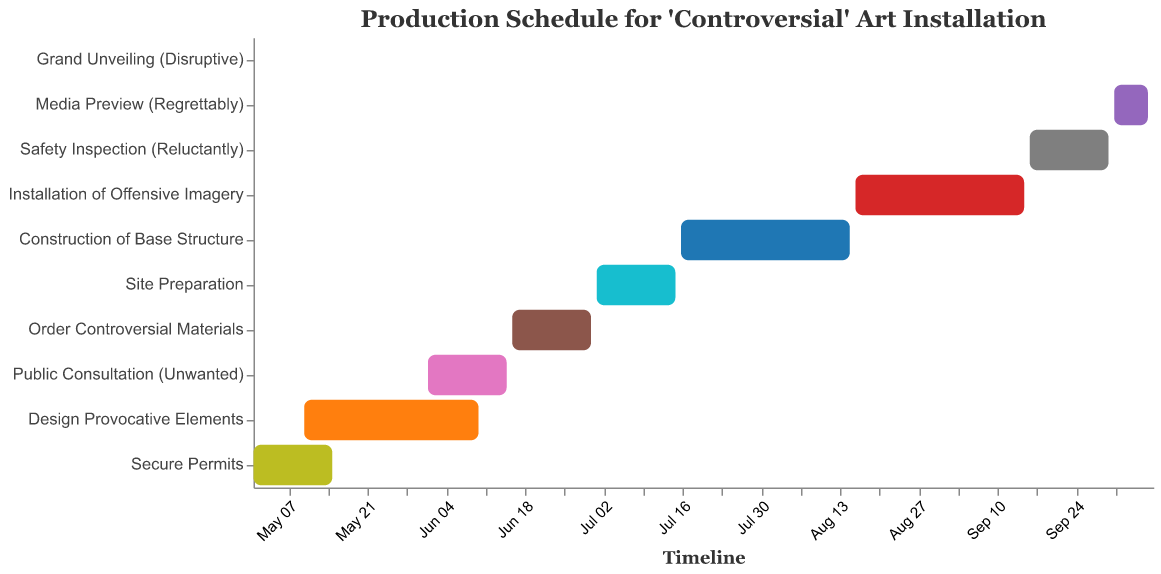What is the first task in the production schedule? The first task listed in the production schedule, indicated at the top of the Y-axis, is "Secure Permits."
Answer: Secure Permits How long is the "Design Provocative Elements" task scheduled to take? The "Design Provocative Elements" task starts on May 10 and ends on June 10. Calculating the duration involves counting the number of days between these two dates (both inclusive).
Answer: 32 days Which task overlaps with "Design Provocative Elements"? By looking at the timeline, "Secure Permits" overlaps with "Design Provocative Elements," as both tasks occur between May 10 and May 15.
Answer: Secure Permits Which task takes place immediately before "Safety Inspection (Reluctantly)"? Referring to the timeline, the task that ends right before "Safety Inspection (Reluctantly)" begins is the "Installation of Offensive Imagery," which ends on September 15.
Answer: Installation of Offensive Imagery What is the total duration of the production schedule from the first task to the last? The production schedule starts with "Secure Permits" on May 1 and ends with the "Grand Unveiling (Disruptive)" on October 8. Calculating the duration from May 1 to October 8 gives a total span of 161 days.
Answer: 161 days Which task has the shortest duration, and how long is it? The task "Grand Unveiling (Disruptive)" has the shortest duration, lasting only one day, on October 8.
Answer: Grand Unveiling (Disruptive), 1 day During which month does the "Public Consultation (Unwanted)" take place? Referring to the timeline, the "Public Consultation (Unwanted)" takes place between June 1 and June 15, entirely within the month of June.
Answer: June Which tasks are scheduled to begin on the first day of a month? Looking at the start dates on the timeline, "Public Consultation (Unwanted)" starts on June 1, and "Site Preparation" starts on July 1.
Answer: Public Consultation (Unwanted), Site Preparation How many tasks are scheduled to take place in August? The timeline indicates two tasks taking place in August: "Construction of Base Structure" (from July 16 to August 15) and "Installation of Offensive Imagery" (from August 16 to September 15).
Answer: 2 